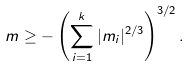Convert formula to latex. <formula><loc_0><loc_0><loc_500><loc_500>m \geq - \left ( \sum _ { i = 1 } ^ { k } | m _ { i } | ^ { 2 / 3 } \right ) ^ { 3 / 2 } .</formula> 